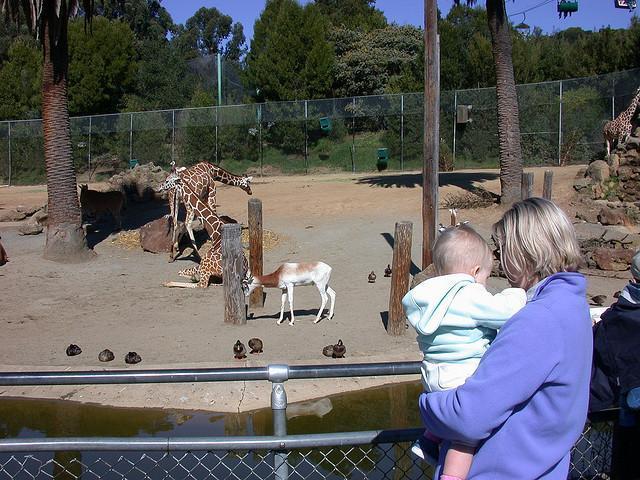What are the birds in the pen called?
From the following set of four choices, select the accurate answer to respond to the question.
Options: Storks, pelicans, ducks, flamingos. Ducks. 